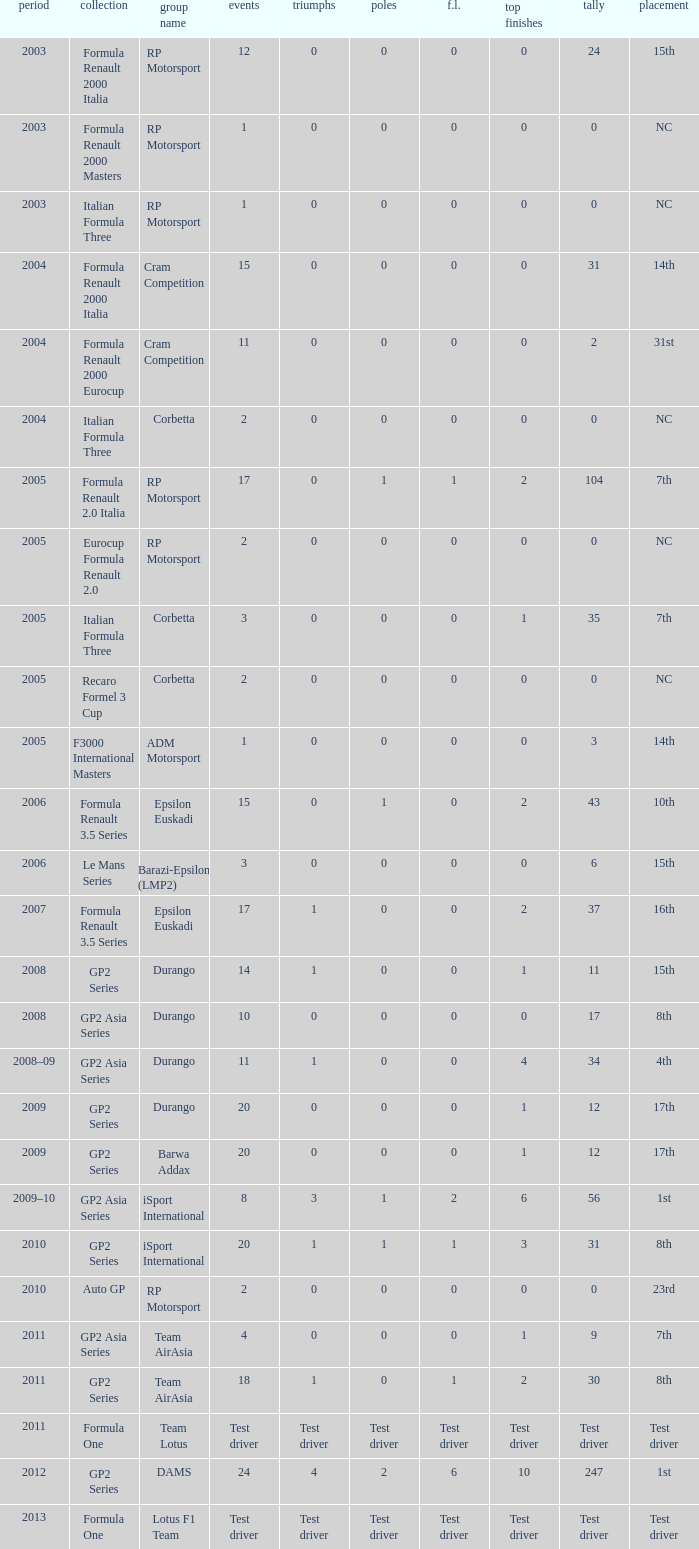What is the number of podiums with 0 wins, 0 F.L. and 35 points? 1.0. 